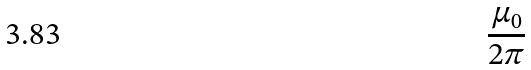Convert formula to latex. <formula><loc_0><loc_0><loc_500><loc_500>\frac { \mu _ { 0 } } { 2 \pi }</formula> 